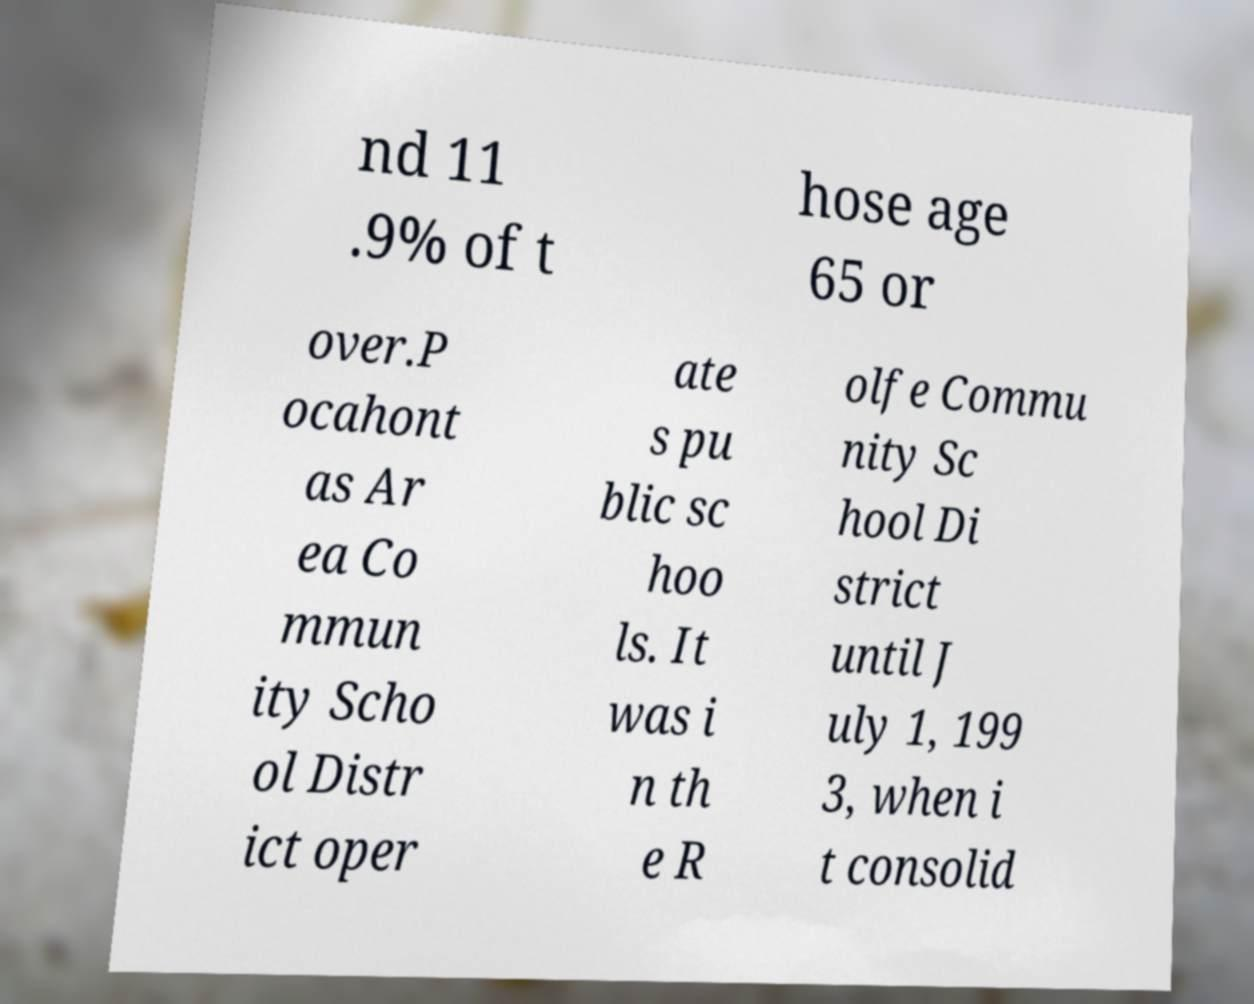Can you accurately transcribe the text from the provided image for me? nd 11 .9% of t hose age 65 or over.P ocahont as Ar ea Co mmun ity Scho ol Distr ict oper ate s pu blic sc hoo ls. It was i n th e R olfe Commu nity Sc hool Di strict until J uly 1, 199 3, when i t consolid 